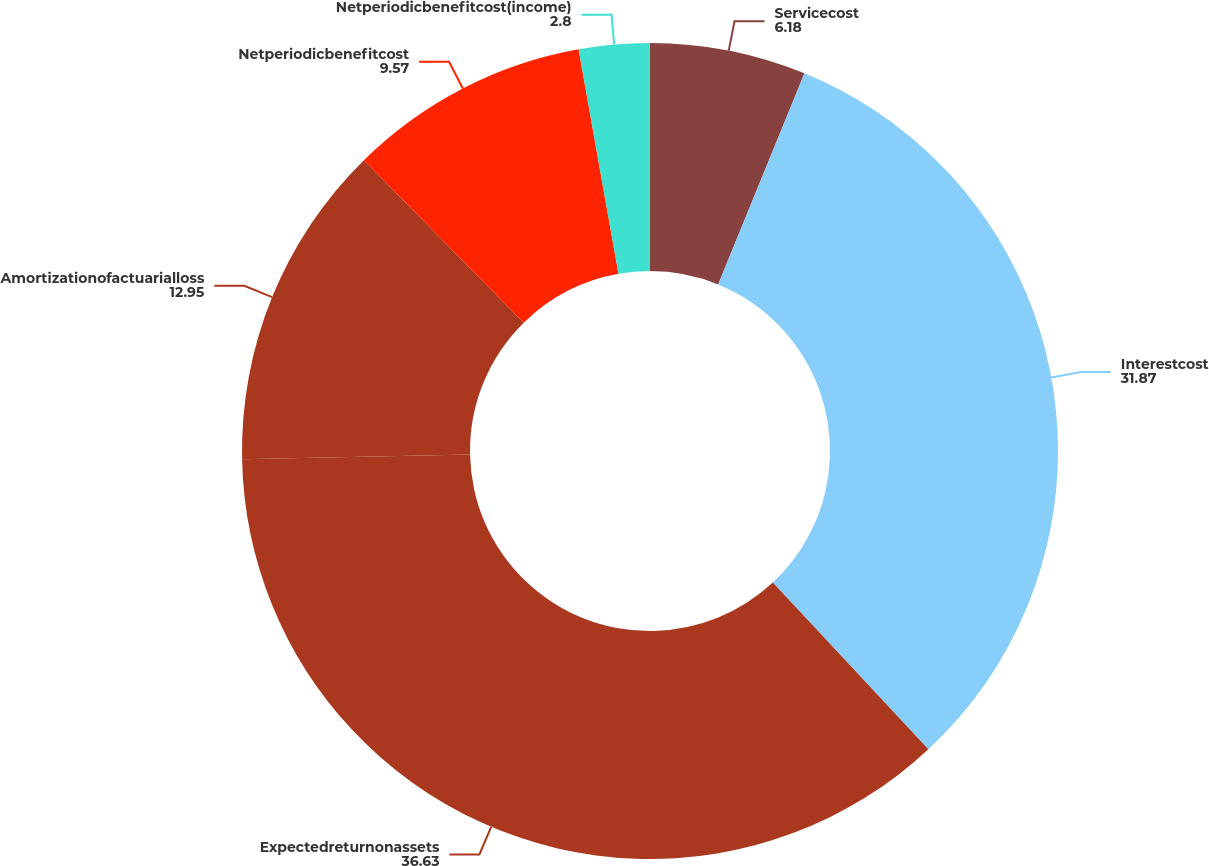Convert chart to OTSL. <chart><loc_0><loc_0><loc_500><loc_500><pie_chart><fcel>Servicecost<fcel>Interestcost<fcel>Expectedreturnonassets<fcel>Amortizationofactuarialloss<fcel>Netperiodicbenefitcost<fcel>Netperiodicbenefitcost(income)<nl><fcel>6.18%<fcel>31.87%<fcel>36.63%<fcel>12.95%<fcel>9.57%<fcel>2.8%<nl></chart> 